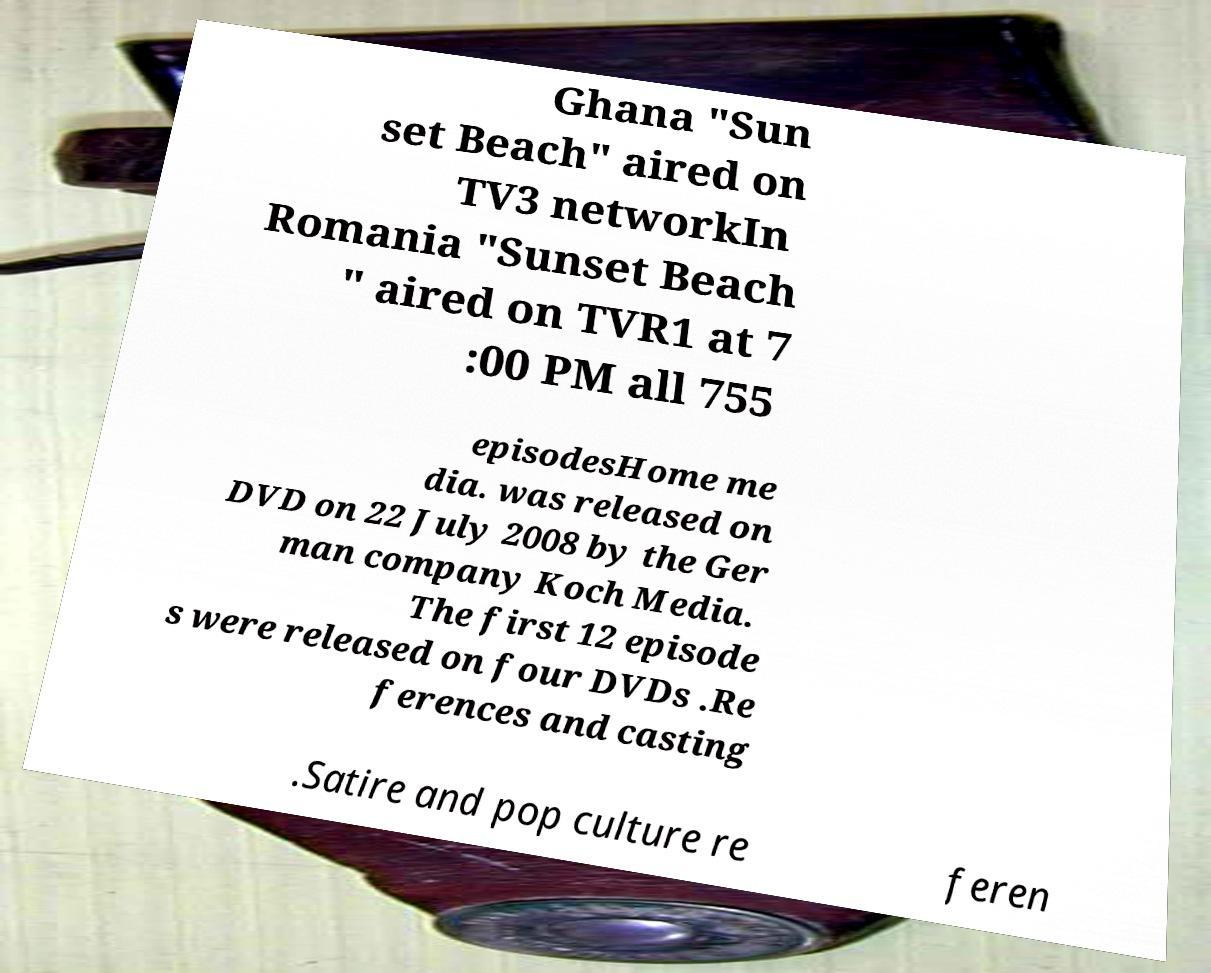Can you read and provide the text displayed in the image?This photo seems to have some interesting text. Can you extract and type it out for me? Ghana "Sun set Beach" aired on TV3 networkIn Romania "Sunset Beach " aired on TVR1 at 7 :00 PM all 755 episodesHome me dia. was released on DVD on 22 July 2008 by the Ger man company Koch Media. The first 12 episode s were released on four DVDs .Re ferences and casting .Satire and pop culture re feren 